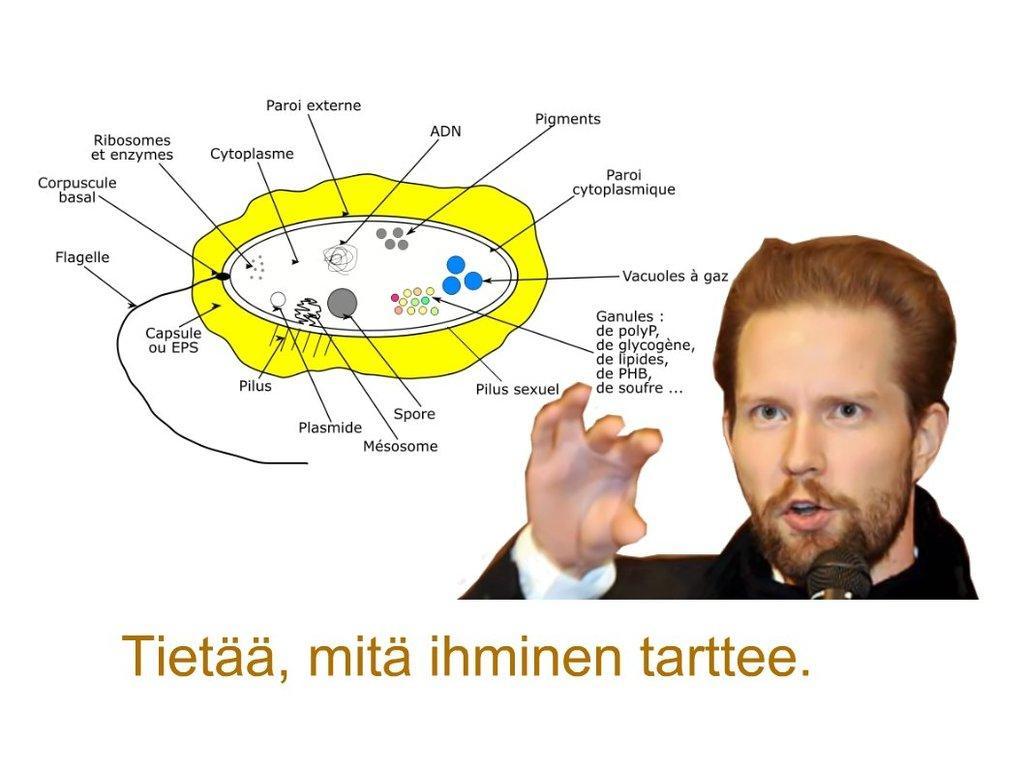Describe this image in one or two sentences. On the right side of the image we can see a man, he is holding a microphone, and we can find some text. 